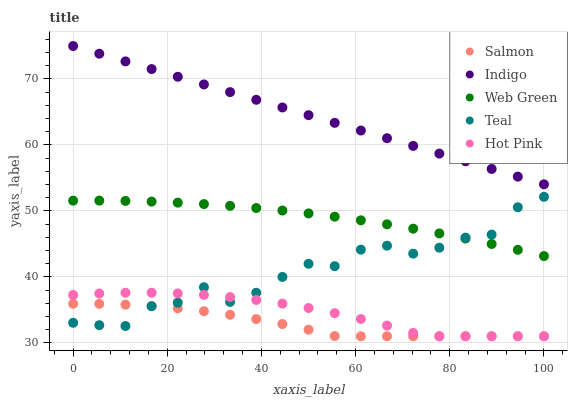Does Salmon have the minimum area under the curve?
Answer yes or no. Yes. Does Indigo have the maximum area under the curve?
Answer yes or no. Yes. Does Hot Pink have the minimum area under the curve?
Answer yes or no. No. Does Hot Pink have the maximum area under the curve?
Answer yes or no. No. Is Indigo the smoothest?
Answer yes or no. Yes. Is Teal the roughest?
Answer yes or no. Yes. Is Hot Pink the smoothest?
Answer yes or no. No. Is Hot Pink the roughest?
Answer yes or no. No. Does Hot Pink have the lowest value?
Answer yes or no. Yes. Does Teal have the lowest value?
Answer yes or no. No. Does Indigo have the highest value?
Answer yes or no. Yes. Does Hot Pink have the highest value?
Answer yes or no. No. Is Hot Pink less than Web Green?
Answer yes or no. Yes. Is Indigo greater than Teal?
Answer yes or no. Yes. Does Teal intersect Web Green?
Answer yes or no. Yes. Is Teal less than Web Green?
Answer yes or no. No. Is Teal greater than Web Green?
Answer yes or no. No. Does Hot Pink intersect Web Green?
Answer yes or no. No. 